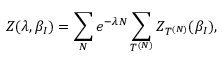<formula> <loc_0><loc_0><loc_500><loc_500>Z ( \lambda , \beta _ { I } ) = \sum _ { N } e ^ { - \lambda N } \sum _ { T ^ { ( N ) } } Z _ { T ^ { ( N ) } } ( \beta _ { I } ) ,</formula> 